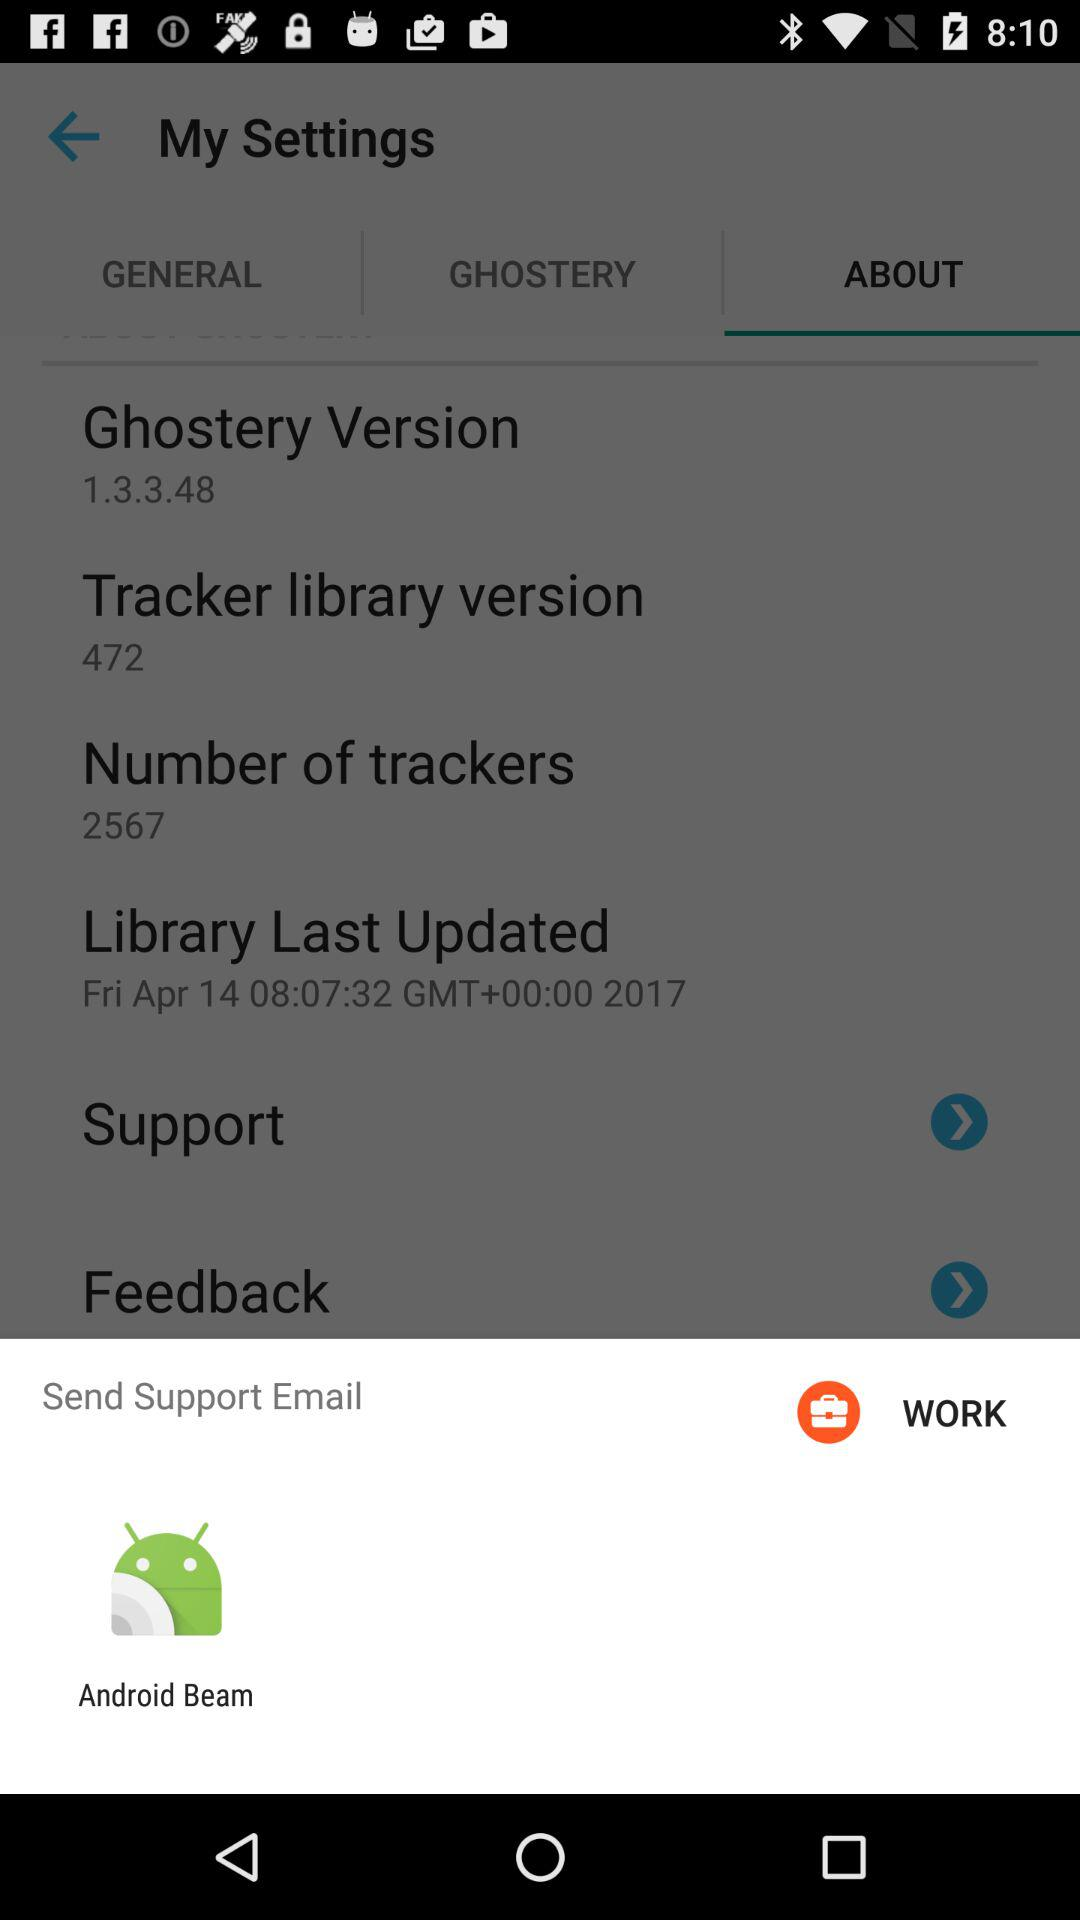What application can be used to send support email? The application that can be used to send support email is "Android Beam". 